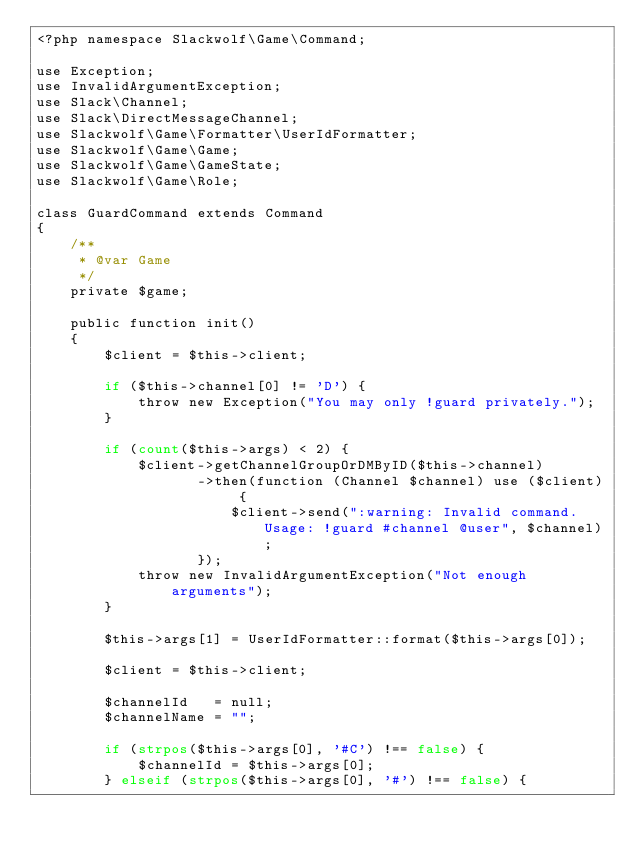Convert code to text. <code><loc_0><loc_0><loc_500><loc_500><_PHP_><?php namespace Slackwolf\Game\Command;

use Exception;
use InvalidArgumentException;
use Slack\Channel;
use Slack\DirectMessageChannel;
use Slackwolf\Game\Formatter\UserIdFormatter;
use Slackwolf\Game\Game;
use Slackwolf\Game\GameState;
use Slackwolf\Game\Role;

class GuardCommand extends Command
{
    /**
     * @var Game
     */
    private $game;

    public function init()
    {
        $client = $this->client;

        if ($this->channel[0] != 'D') {
            throw new Exception("You may only !guard privately.");
        }

        if (count($this->args) < 2) {
            $client->getChannelGroupOrDMByID($this->channel)
                   ->then(function (Channel $channel) use ($client) {
                       $client->send(":warning: Invalid command. Usage: !guard #channel @user", $channel);
                   });
            throw new InvalidArgumentException("Not enough arguments");
        }

        $this->args[1] = UserIdFormatter::format($this->args[0]);

        $client = $this->client;

        $channelId   = null;
        $channelName = "";

        if (strpos($this->args[0], '#C') !== false) {
            $channelId = $this->args[0];
        } elseif (strpos($this->args[0], '#') !== false) {</code> 